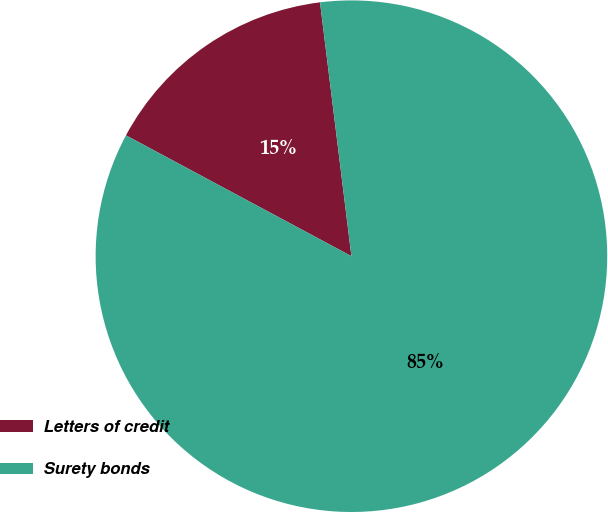Convert chart. <chart><loc_0><loc_0><loc_500><loc_500><pie_chart><fcel>Letters of credit<fcel>Surety bonds<nl><fcel>15.21%<fcel>84.79%<nl></chart> 